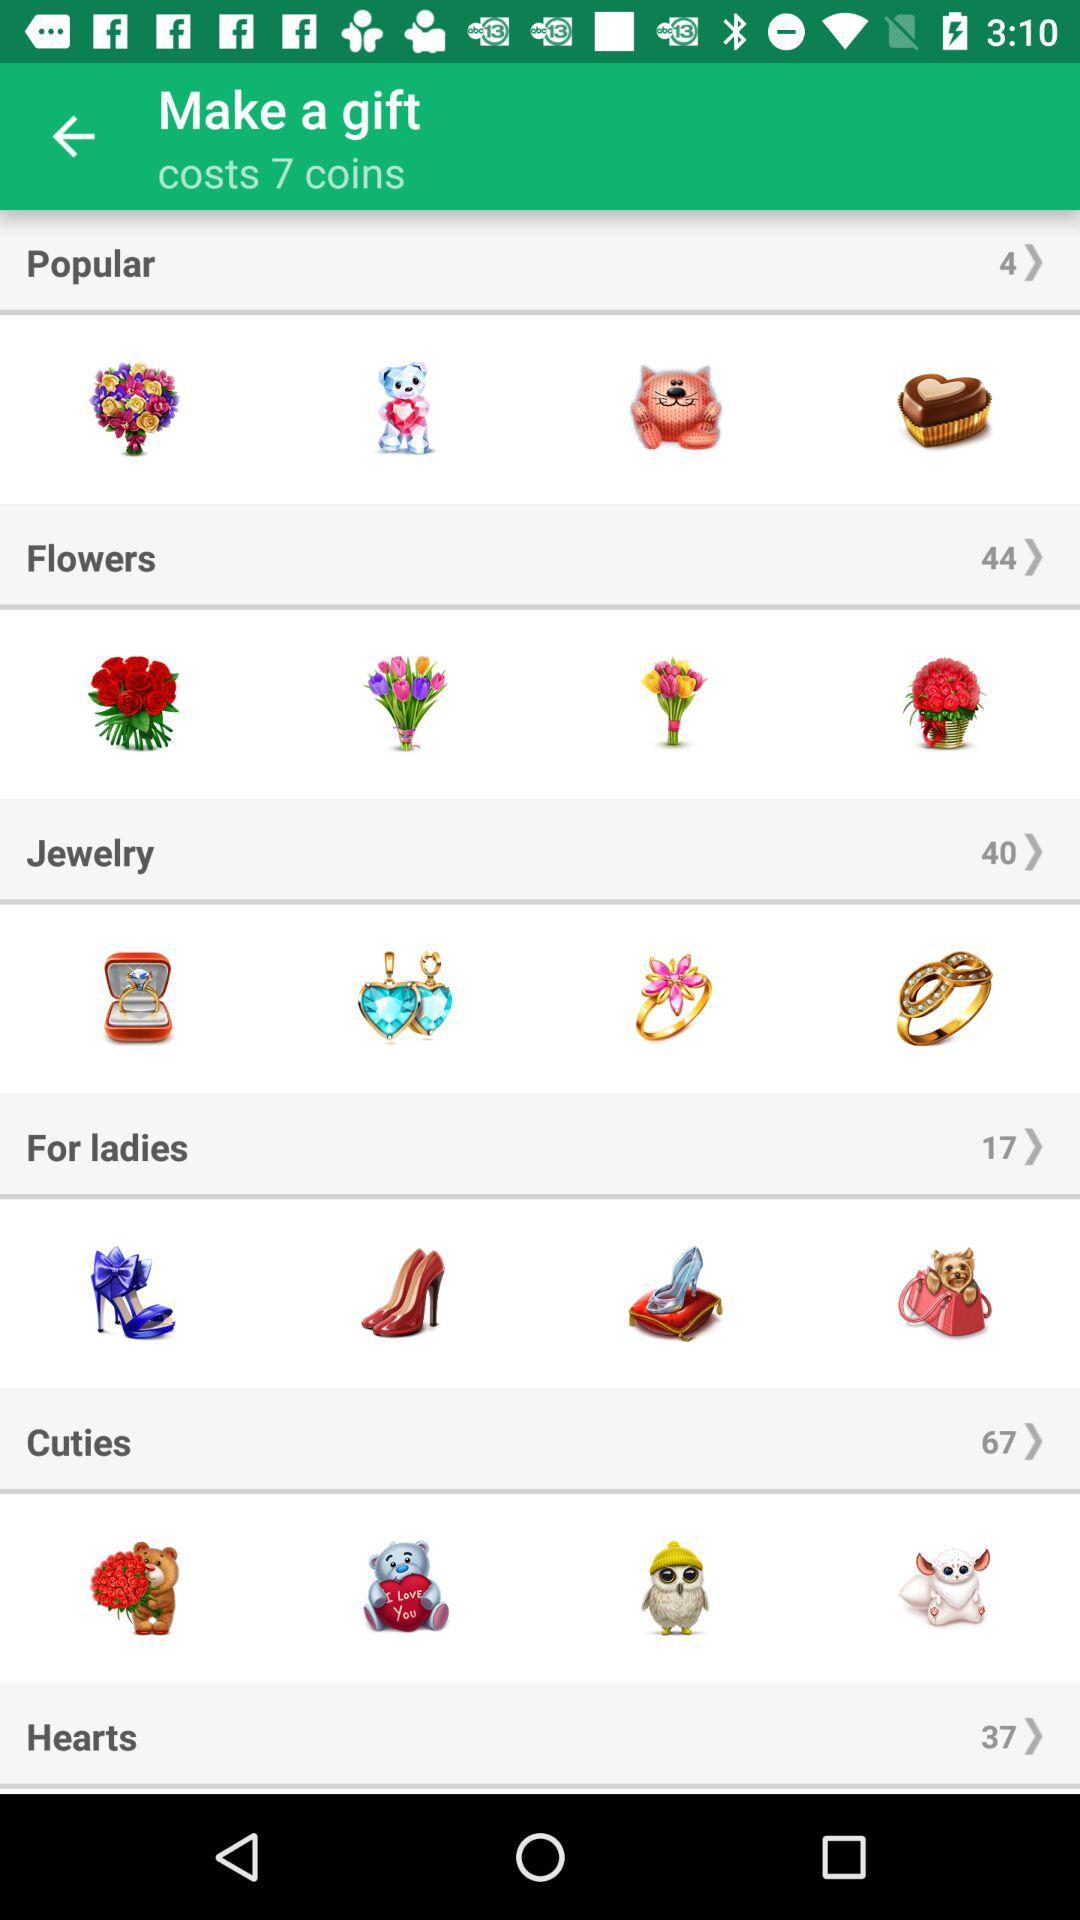What's the total number of "Popular" gifts? The total number of "Popular" gifts is 4. 